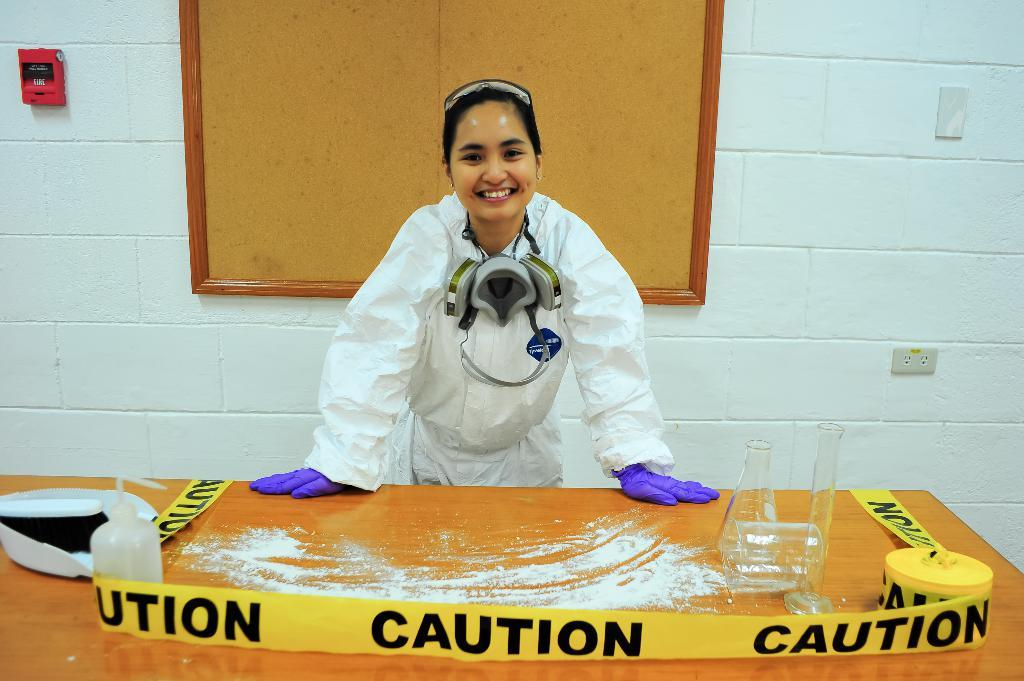What substance can be seen in the image? There is powder in the image. What safety measure is present in the image? There is caution tape in the image. What type of container is visible in the image? There is a spray bottle in the image. What tools are used for measuring in the image? There is a measuring jar and a measuring flask in the image. Where are the objects located in the image? The objects are on a table in the image. What is the woman in the image doing? The woman is standing and smiling in the image. What is attached to the wall in the image? There is a board attached to the wall in the image. Can you see any snails crawling on the stove in the image? There is no stove or snails present in the image. What type of playground equipment can be seen in the image? There is no playground equipment present in the image. 